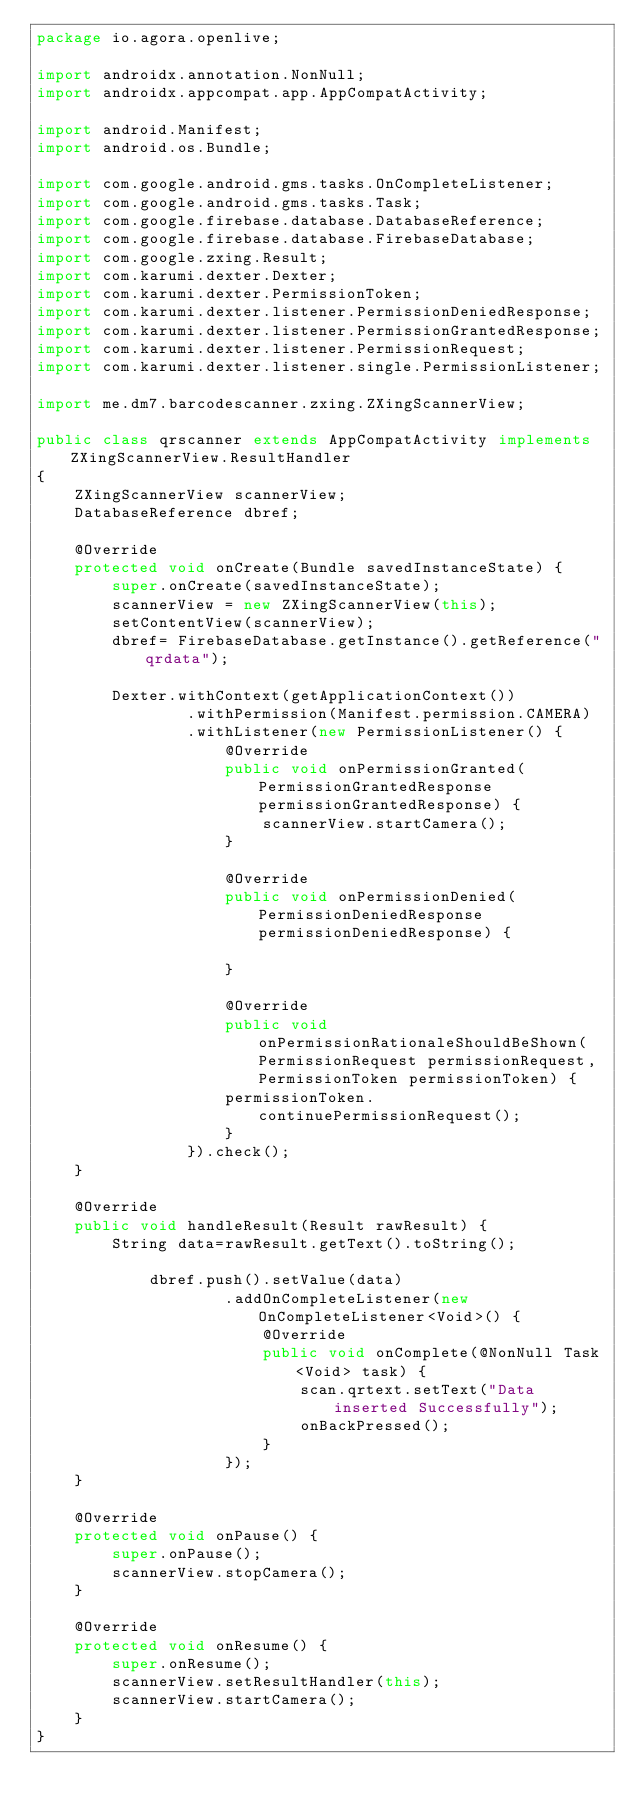<code> <loc_0><loc_0><loc_500><loc_500><_Java_>package io.agora.openlive;

import androidx.annotation.NonNull;
import androidx.appcompat.app.AppCompatActivity;

import android.Manifest;
import android.os.Bundle;

import com.google.android.gms.tasks.OnCompleteListener;
import com.google.android.gms.tasks.Task;
import com.google.firebase.database.DatabaseReference;
import com.google.firebase.database.FirebaseDatabase;
import com.google.zxing.Result;
import com.karumi.dexter.Dexter;
import com.karumi.dexter.PermissionToken;
import com.karumi.dexter.listener.PermissionDeniedResponse;
import com.karumi.dexter.listener.PermissionGrantedResponse;
import com.karumi.dexter.listener.PermissionRequest;
import com.karumi.dexter.listener.single.PermissionListener;

import me.dm7.barcodescanner.zxing.ZXingScannerView;

public class qrscanner extends AppCompatActivity implements ZXingScannerView.ResultHandler
{
    ZXingScannerView scannerView;
    DatabaseReference dbref;

    @Override
    protected void onCreate(Bundle savedInstanceState) {
        super.onCreate(savedInstanceState);
        scannerView = new ZXingScannerView(this);
        setContentView(scannerView);
        dbref= FirebaseDatabase.getInstance().getReference("qrdata");

        Dexter.withContext(getApplicationContext())
                .withPermission(Manifest.permission.CAMERA)
                .withListener(new PermissionListener() {
                    @Override
                    public void onPermissionGranted(PermissionGrantedResponse permissionGrantedResponse) {
                        scannerView.startCamera();
                    }

                    @Override
                    public void onPermissionDenied(PermissionDeniedResponse permissionDeniedResponse) {

                    }

                    @Override
                    public void onPermissionRationaleShouldBeShown(PermissionRequest permissionRequest, PermissionToken permissionToken) {
                    permissionToken.continuePermissionRequest();
                    }
                }).check();
    }

    @Override
    public void handleResult(Result rawResult) {
        String data=rawResult.getText().toString();

            dbref.push().setValue(data)
                    .addOnCompleteListener(new OnCompleteListener<Void>() {
                        @Override
                        public void onComplete(@NonNull Task<Void> task) {
                            scan.qrtext.setText("Data inserted Successfully");
                            onBackPressed();
                        }
                    });
    }

    @Override
    protected void onPause() {
        super.onPause();
        scannerView.stopCamera();
    }

    @Override
    protected void onResume() {
        super.onResume();
        scannerView.setResultHandler(this);
        scannerView.startCamera();
    }
}</code> 